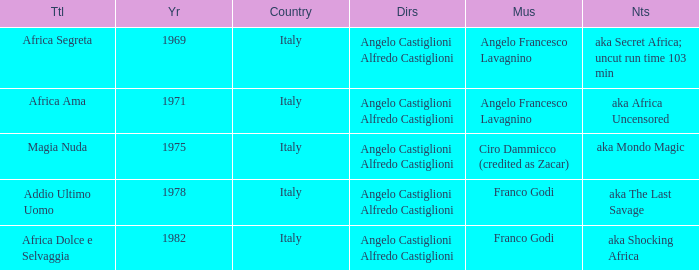What is the country that has a music writer of Angelo Francesco Lavagnino, written in 1969? Italy. 